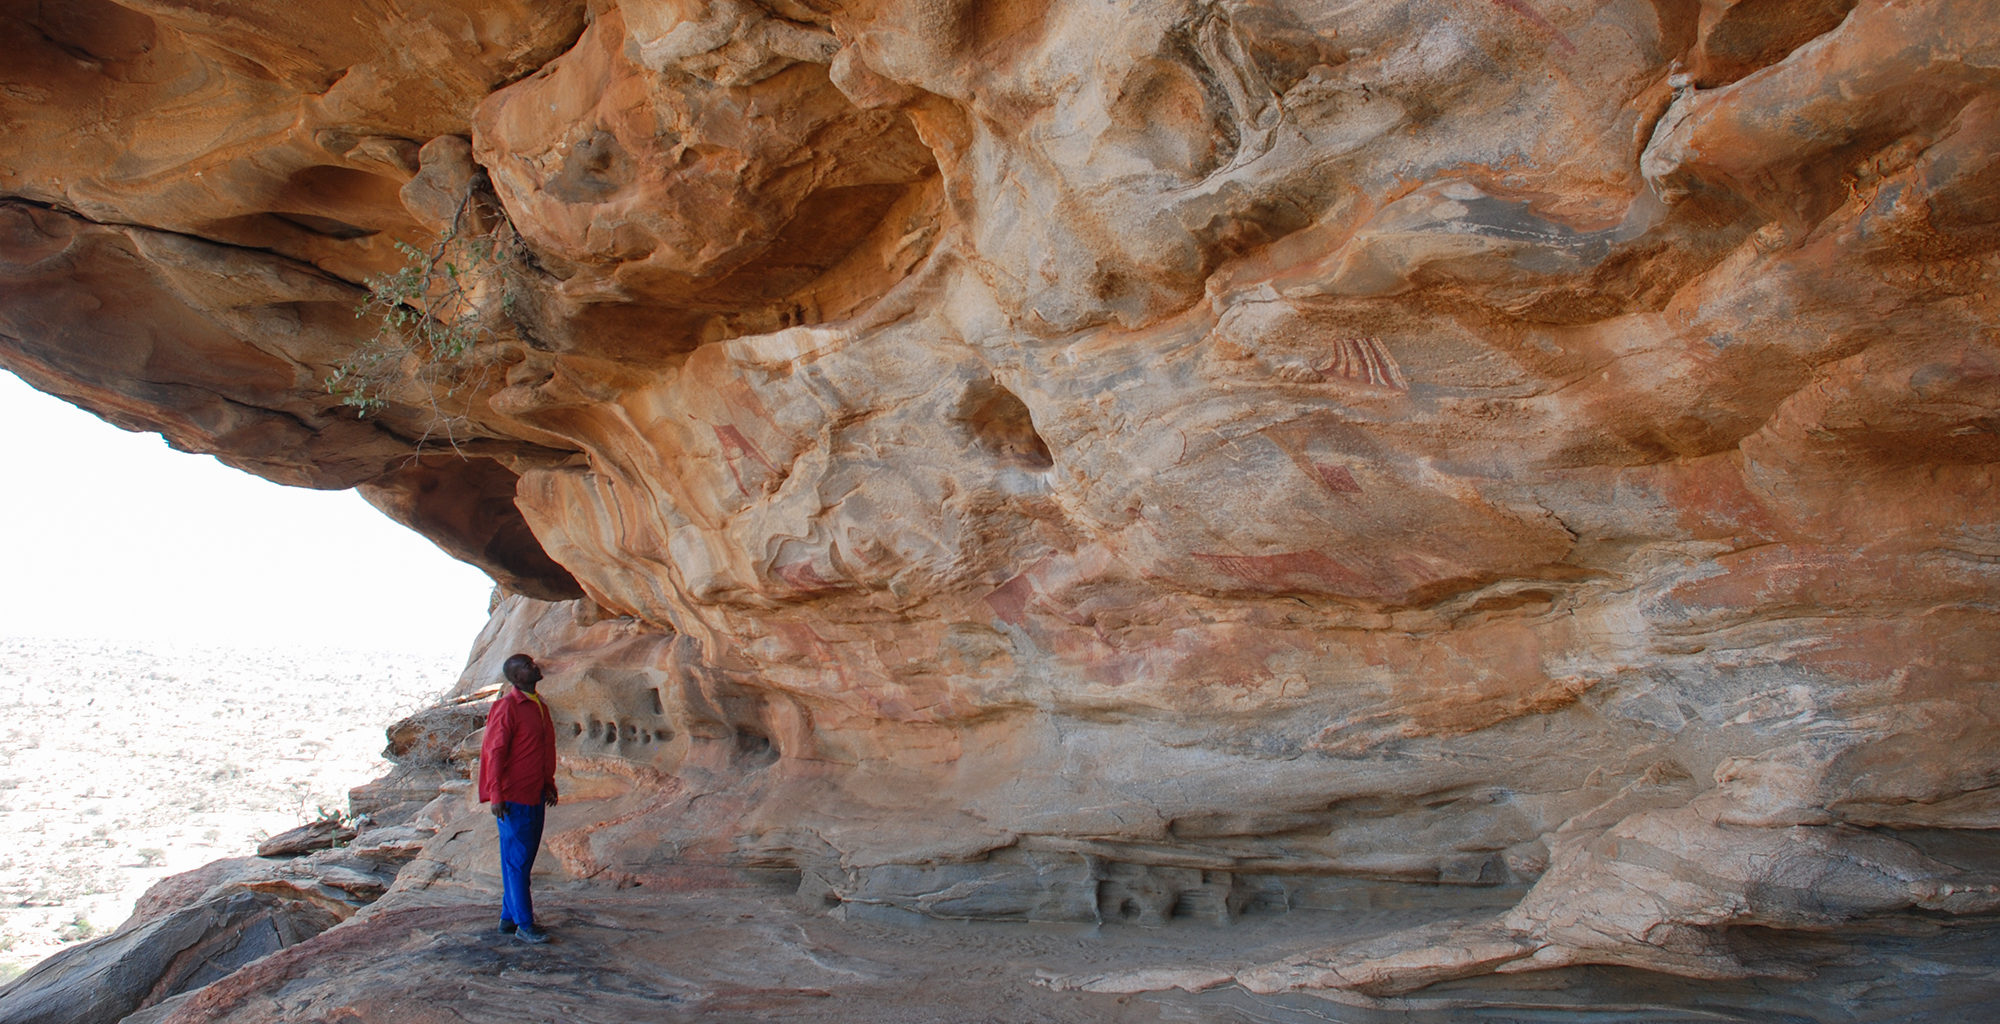Imagine that an ancient ritual is being performed in front of this rock art. Describe it in detail. As the sun sets and the vast desert is bathed in twilight, a group of ancient tribespeople gather in front of the rock art, ready to perform a sacred ritual handed down through generations. Chanting in a language long forgotten, they form a circle around a central fire, the flickering flames casting shadows that dance across the rock paintings. Dressed in traditional attire adorned with beads and feathers, the tribe's elders lead the ritual with rhythmic drumming and harmonious chanting. They offer tributes of food and crafted items to the spirits believed to inhabit the cave, while younger members paint their faces with ochre and clay, mimicking the ancient art on the walls. The ritual peaks as the chief, holding a ceremonial staff and adorned in robes of woven grass and animal hide, calls upon the ancestors for guidance and protection. The air is thick with smoke and the scent of burning herbs, creating an atmosphere of reverence and mystical connection to the past, while the painted figures on the walls seem to come alive in the firelight, breathing life into the tales they silently tell. 